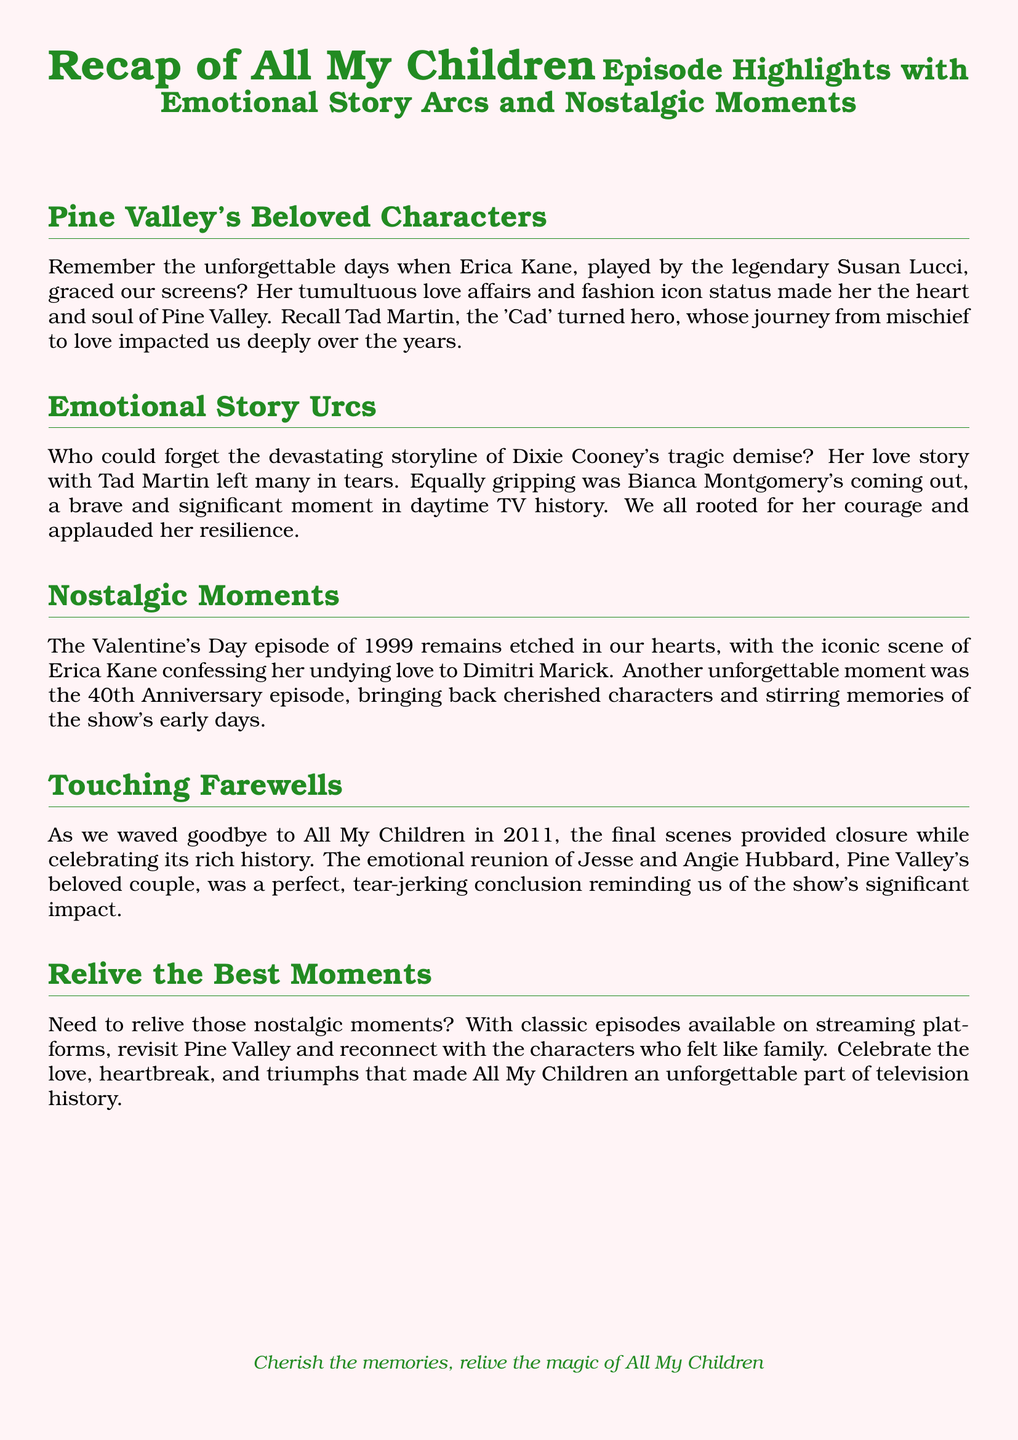What character did Susan Lucci portray? Susan Lucci portrayed the iconic character Erica Kane, who was a central figure in the series.
Answer: Erica Kane What significant storyline involved Bianca Montgomery? Bianca Montgomery's coming out was a crucial and brave storyline in the show, touching on important themes of identity and acceptance.
Answer: Coming out Which couple's emotional reunion was highlighted in the farewell episode? The reunion of Jesse and Angie Hubbard was a touching moment in the series finale, showcasing the enduring love between these characters.
Answer: Jesse and Angie Hubbard What year was the memorable Valentine's Day episode? The Valentine's Day episode that many fans recall fondly aired in 1999, marking a significant moment in the series' history.
Answer: 1999 What was the main theme of the document? The document focused on the highlights of "All My Children," including emotional story arcs and nostalgic moments that defined the show.
Answer: Episode Highlights Which character's tragic demise affected fans deeply? Dixie Cooney's tragic demise was a storyline that left a lasting impact, bringing many fans to tears over her love story with Tad Martin.
Answer: Dixie Cooney What was celebrated during the 40th Anniversary episode? The 40th Anniversary episode celebrated the show's legacy by bringing back cherished characters and stirring up memories for long-time fans.
Answer: Cherished characters What year did "All My Children" end? The show concluded in 2011, marking the end of an era for its devoted viewers.
Answer: 2011 What are fans encouraged to do with classic episodes? Fans are encouraged to relive their favorite moments by watching classic episodes available on streaming platforms, reconnecting with the series.
Answer: Revisit Pine Valley 